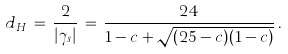<formula> <loc_0><loc_0><loc_500><loc_500>d _ { H } \, = \, \frac { 2 } { | \gamma _ { s } | } \, = \, \frac { 2 4 } { 1 - c + \sqrt { ( 2 5 - c ) ( 1 - c ) } } \, .</formula> 